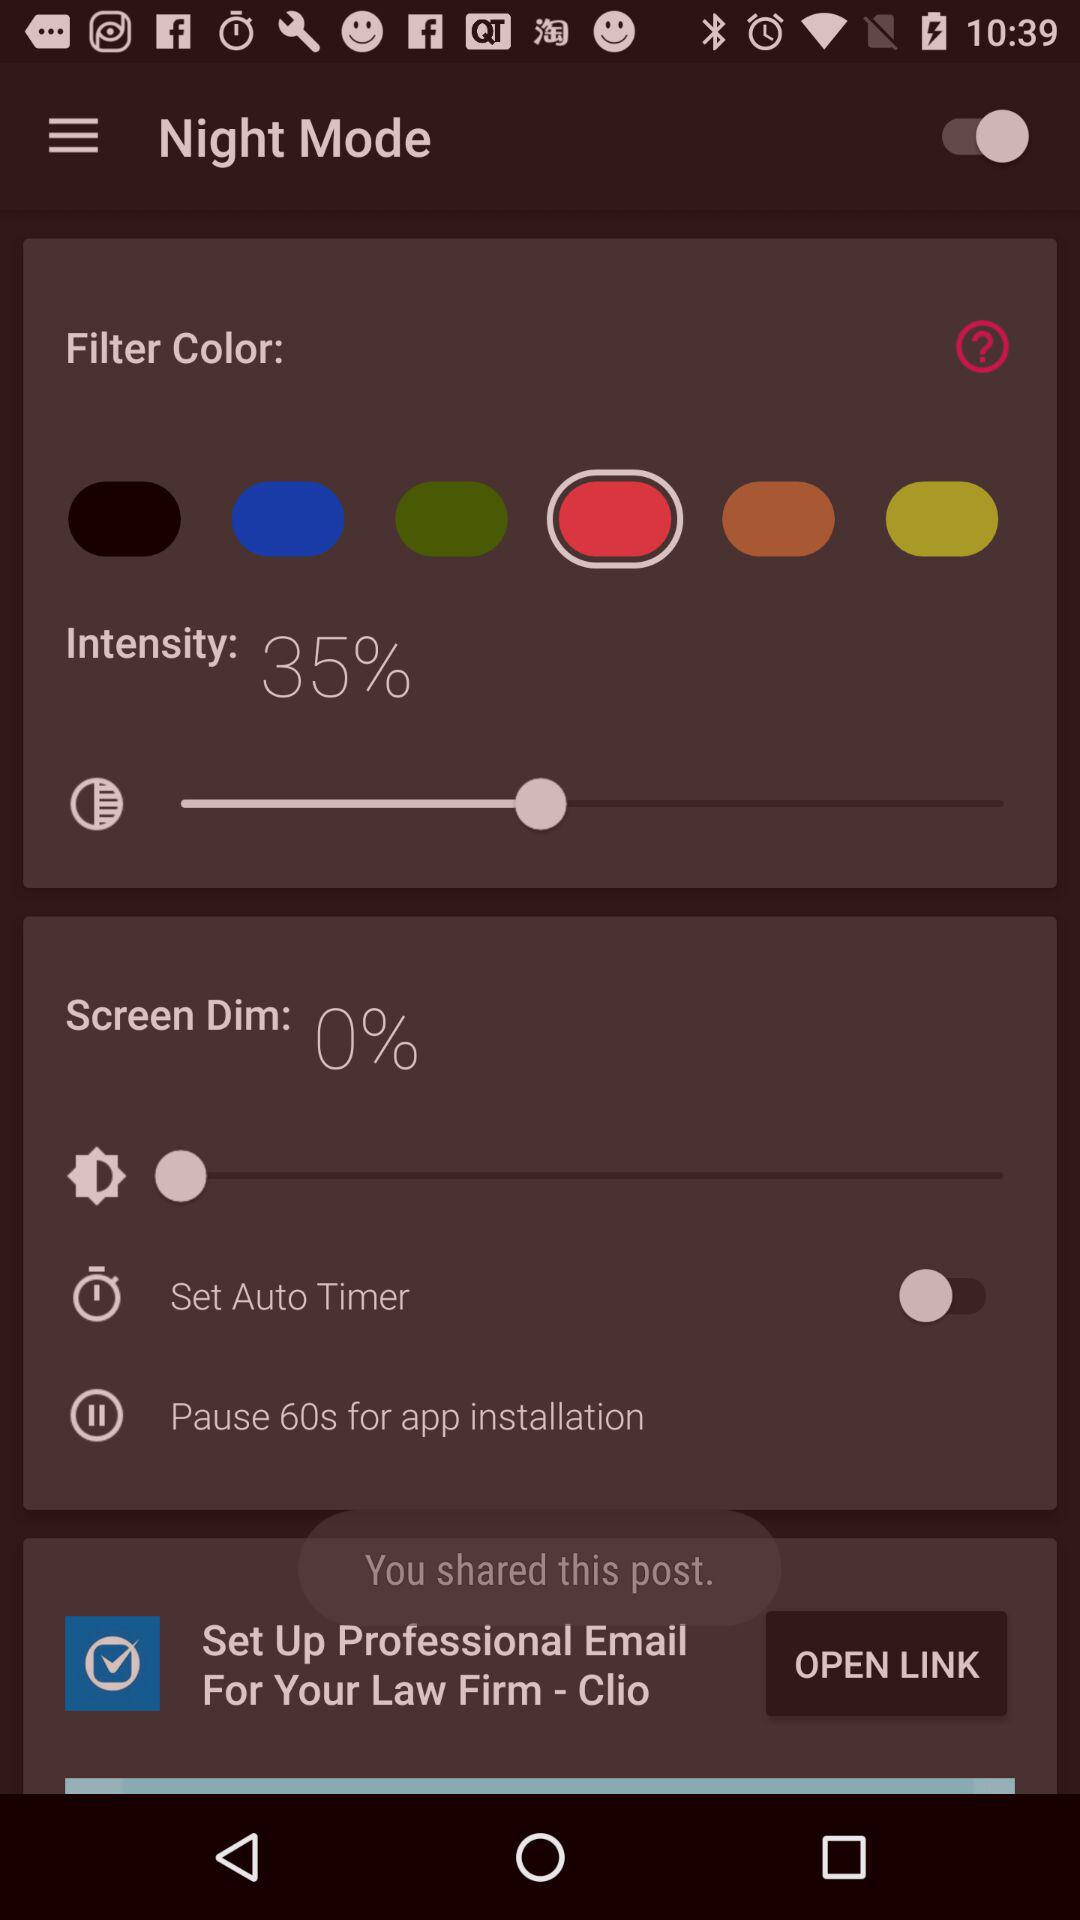What is the status of the "Set Auto Timer"? The status of the "Set Auto Timer" is "off". 